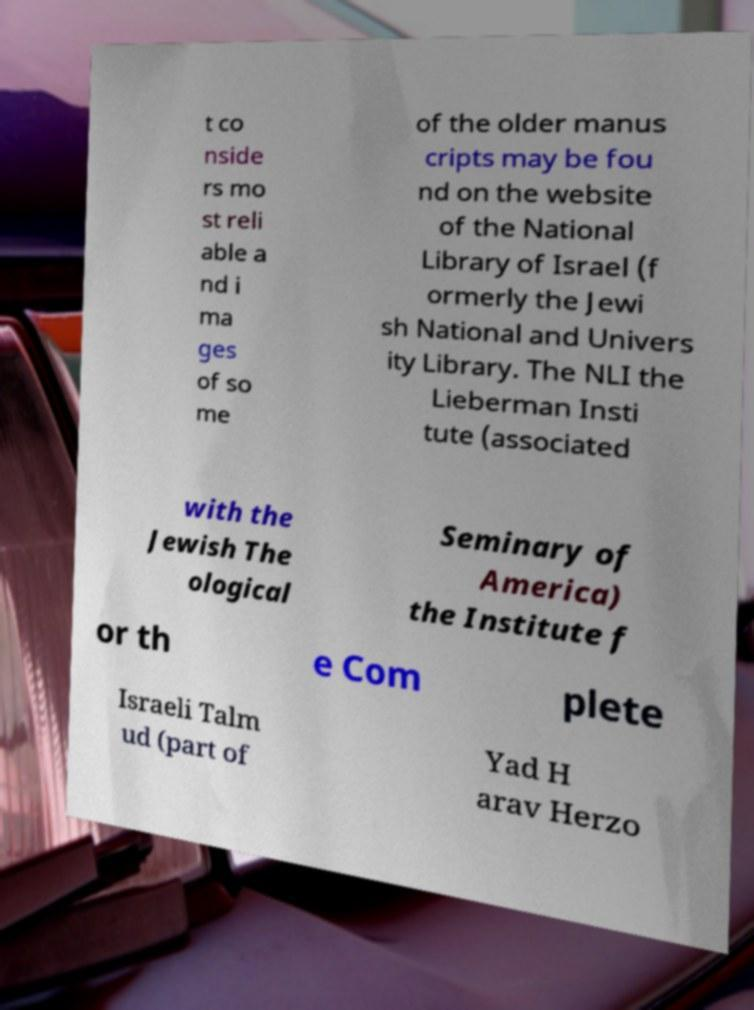There's text embedded in this image that I need extracted. Can you transcribe it verbatim? t co nside rs mo st reli able a nd i ma ges of so me of the older manus cripts may be fou nd on the website of the National Library of Israel (f ormerly the Jewi sh National and Univers ity Library. The NLI the Lieberman Insti tute (associated with the Jewish The ological Seminary of America) the Institute f or th e Com plete Israeli Talm ud (part of Yad H arav Herzo 